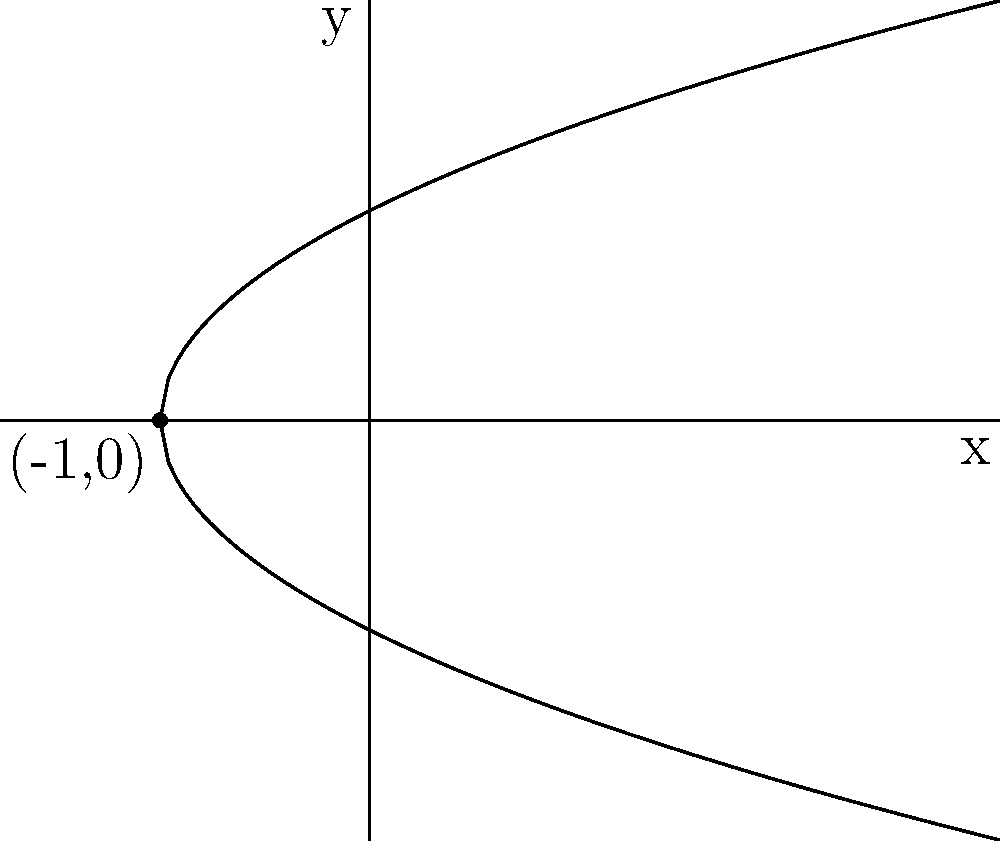As a refugee adapting to life in Ireland, you've been studying mathematics to improve your skills. You come across the following equation: $4x + 4y^2 + 8y - 7 = 0$. What type of conic section does this equation represent, and how does it relate to the graph shown above? Let's approach this step-by-step:

1) First, we need to identify the general form of the equation:
   $4x + 4y^2 + 8y - 7 = 0$

2) To determine the type of conic section, we need to rearrange it into standard form:
   $4y^2 + 8y + 4x - 7 = 0$
   $y^2 + 2y + x - \frac{7}{4} = 0$

3) Complete the square for y:
   $(y^2 + 2y) + x - \frac{7}{4} = 0$
   $(y^2 + 2y + 1) + x - \frac{7}{4} - 1 = 0$
   $(y + 1)^2 + x - \frac{11}{4} = 0$

4) Rearrange to get the final form:
   $x = (y + 1)^2 + \frac{11}{4}$
   $x = (y + 1)^2 + \frac{11}{4}$

5) This is the standard form of a parabola with its axis of symmetry parallel to the y-axis.

6) The vertex of the parabola is at $(-\frac{11}{4}, -1)$, which is equivalent to $(-2.75, -1)$.

7) The parabola opens to the right because the coefficient of $(y + 1)^2$ is positive.

8) Comparing this to the graph:
   - The graph shows a parabola opening to the right
   - The vertex appears to be at $(-1, 0)$, which is close to our calculated vertex
   - The parabola passes through the y-axis at two points, consistent with our equation

While the exact values differ slightly (likely due to rounding in the graph), the overall shape and orientation match our analysis.
Answer: Parabola opening to the right 